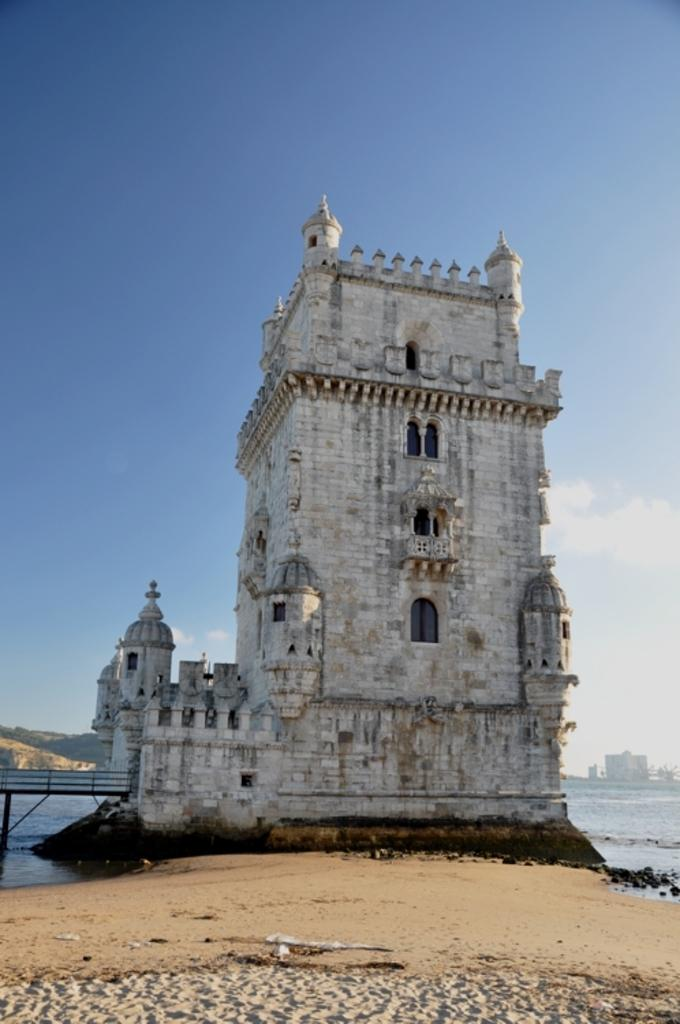What type of structures can be seen in the image? There are buildings in the image. What natural elements are visible in the image? Sand and water are visible in the image. Can you describe the sky in the image? The sky has clouds in it. What else can be seen in the image besides the mentioned elements? There are a few unspecified things in the image. What sense is being triggered by the pigs in the image? There are no pigs present in the image, so no sense is being triggered by them. 